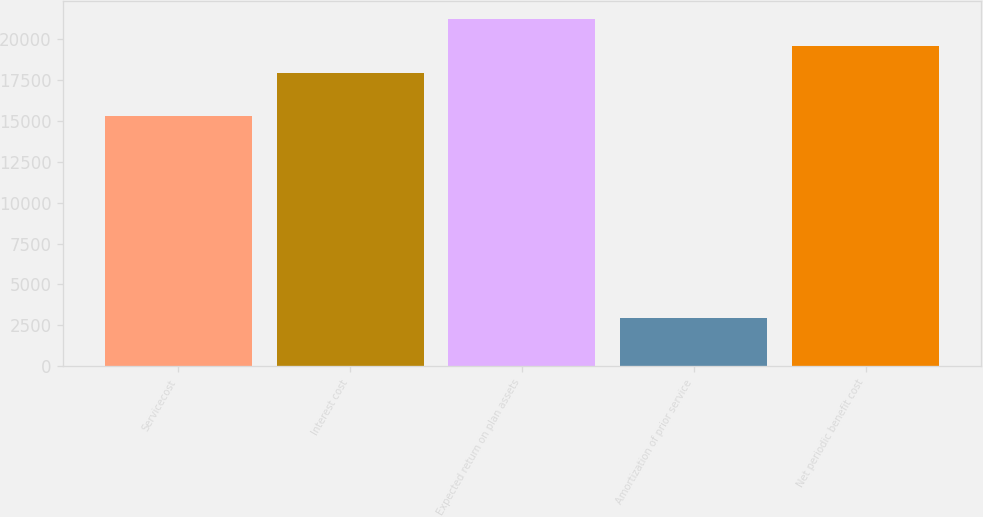<chart> <loc_0><loc_0><loc_500><loc_500><bar_chart><fcel>Servicecost<fcel>Interest cost<fcel>Expected return on plan assets<fcel>Amortization of prior service<fcel>Net periodic benefit cost<nl><fcel>15269<fcel>17945<fcel>21239.6<fcel>2960<fcel>19592.3<nl></chart> 